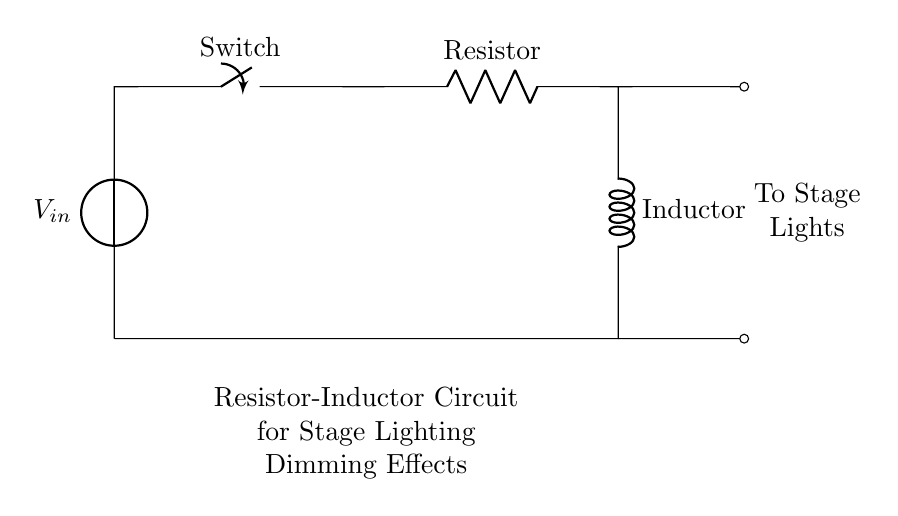What is the purpose of the resistor in this circuit? The resistor limits the current flowing through the circuit, which affects the brightness of the stage lights. By adjusting the resistance, you can dim the lights according to the desired effect.
Answer: Limits current What component is connected directly to the voltage source? The voltage source is directly connected to the switch, indicating that it provides the input voltage to the rest of the circuit and can be turned on or off.
Answer: Switch What does the inductor do in the circuit? The inductor stores energy in a magnetic field when current flows through it. In this circuit, it works with the resistor to create a dimming effect and regulate the current, producing a smoother transition in light intensity.
Answer: Stores energy How many main components are in the circuit? There are three main components: the voltage source, the resistor, and the inductor. Each plays a distinct role in controlling the circuit's behavior and affecting the stage lights.
Answer: Three What effect does increasing the resistance have on the circuit? Increasing the resistance decreases the current flow in the circuit, which leads to a dimming effect on the stage lights. This occurs because less current means less power delivered to the lights.
Answer: Dimming effect Which component allows the circuit to be opened or closed? The switch allows the circuit to be opened or closed, effectively controlling whether the current can flow through the circuit to the stage lights.
Answer: Switch 